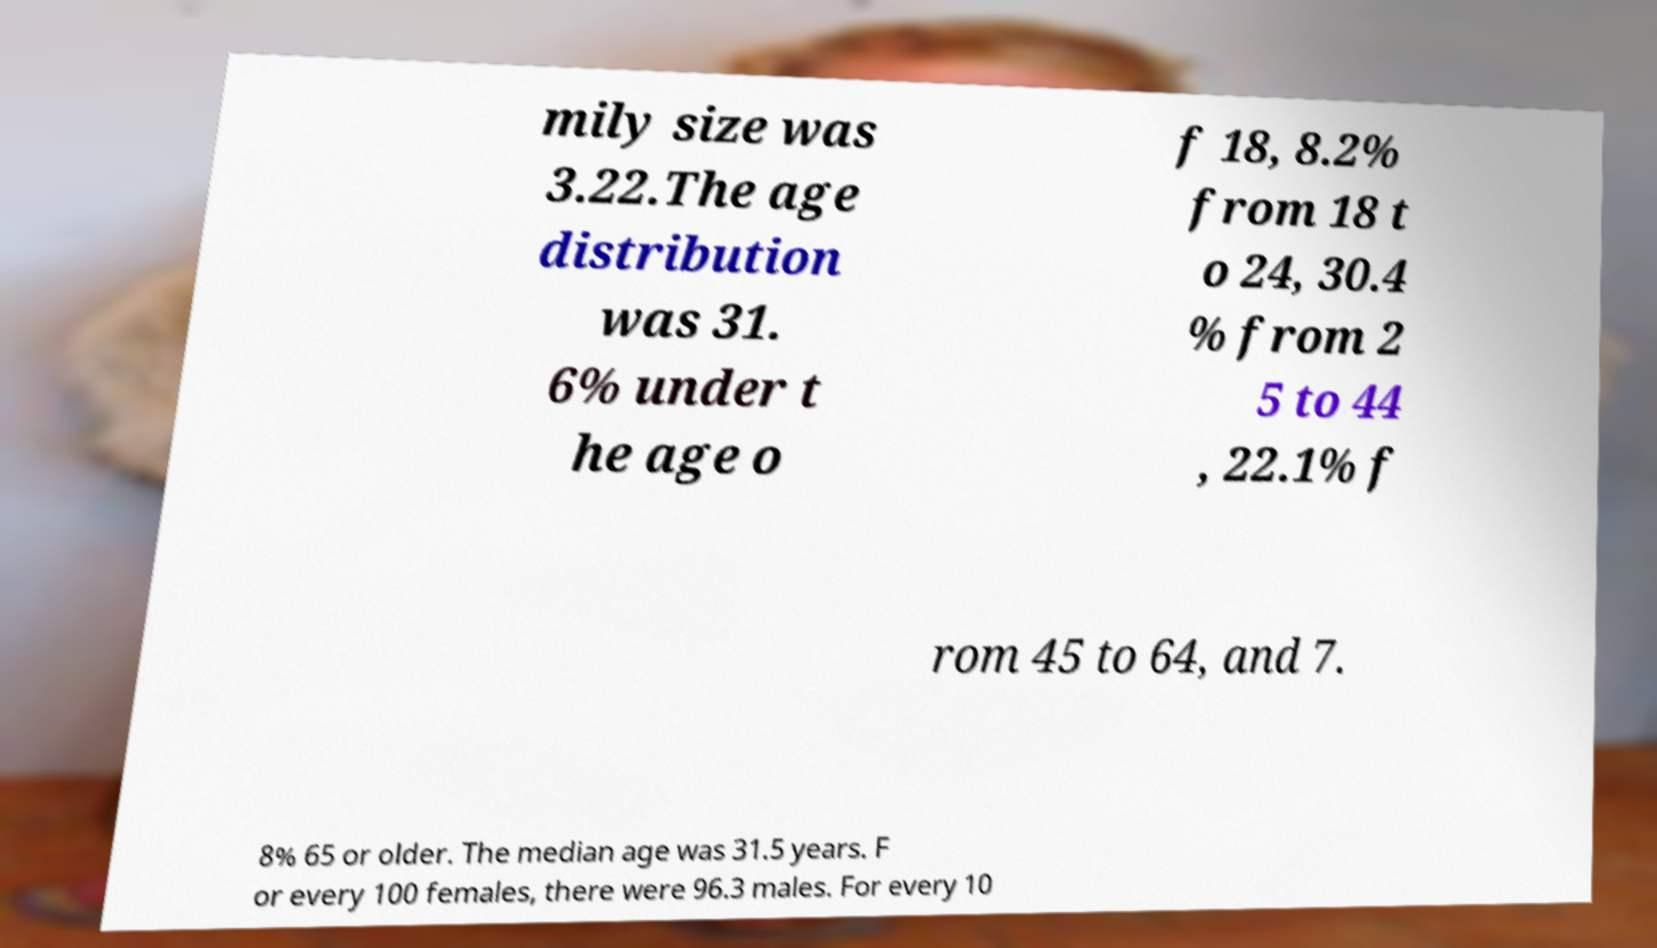Please identify and transcribe the text found in this image. mily size was 3.22.The age distribution was 31. 6% under t he age o f 18, 8.2% from 18 t o 24, 30.4 % from 2 5 to 44 , 22.1% f rom 45 to 64, and 7. 8% 65 or older. The median age was 31.5 years. F or every 100 females, there were 96.3 males. For every 10 